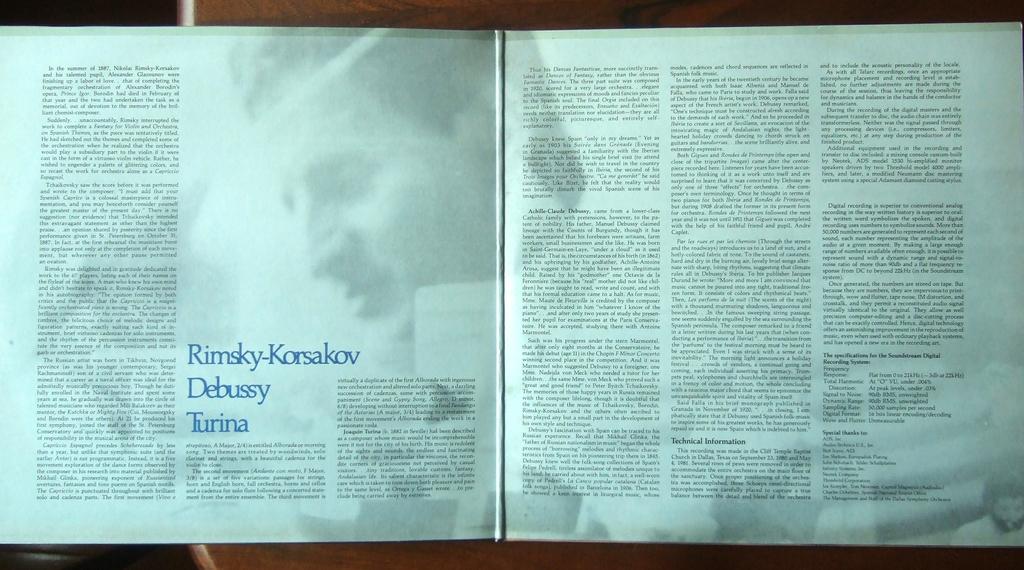What is the name written?
Keep it short and to the point. Rimsky-korsakov debussy turina. Some magazine books?
Give a very brief answer. Yes. 